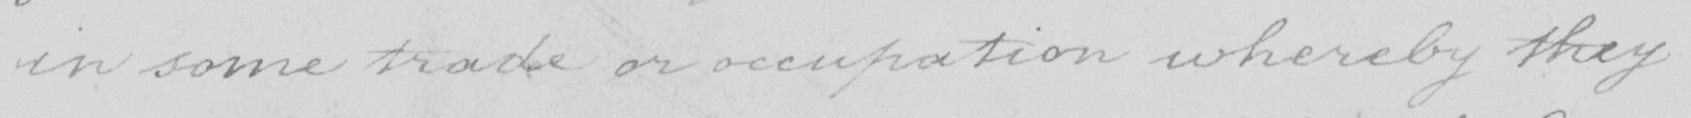Please transcribe the handwritten text in this image. in some trade or occupation whereby they 